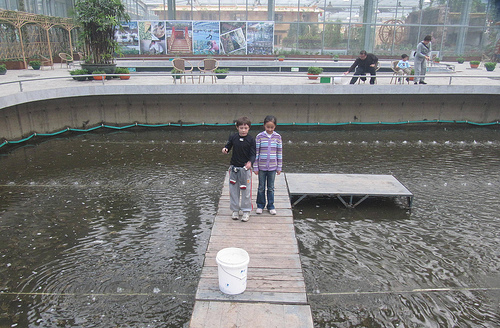<image>
Is the water behind the boy? Yes. From this viewpoint, the water is positioned behind the boy, with the boy partially or fully occluding the water. Is the bucket in the water? No. The bucket is not contained within the water. These objects have a different spatial relationship. 